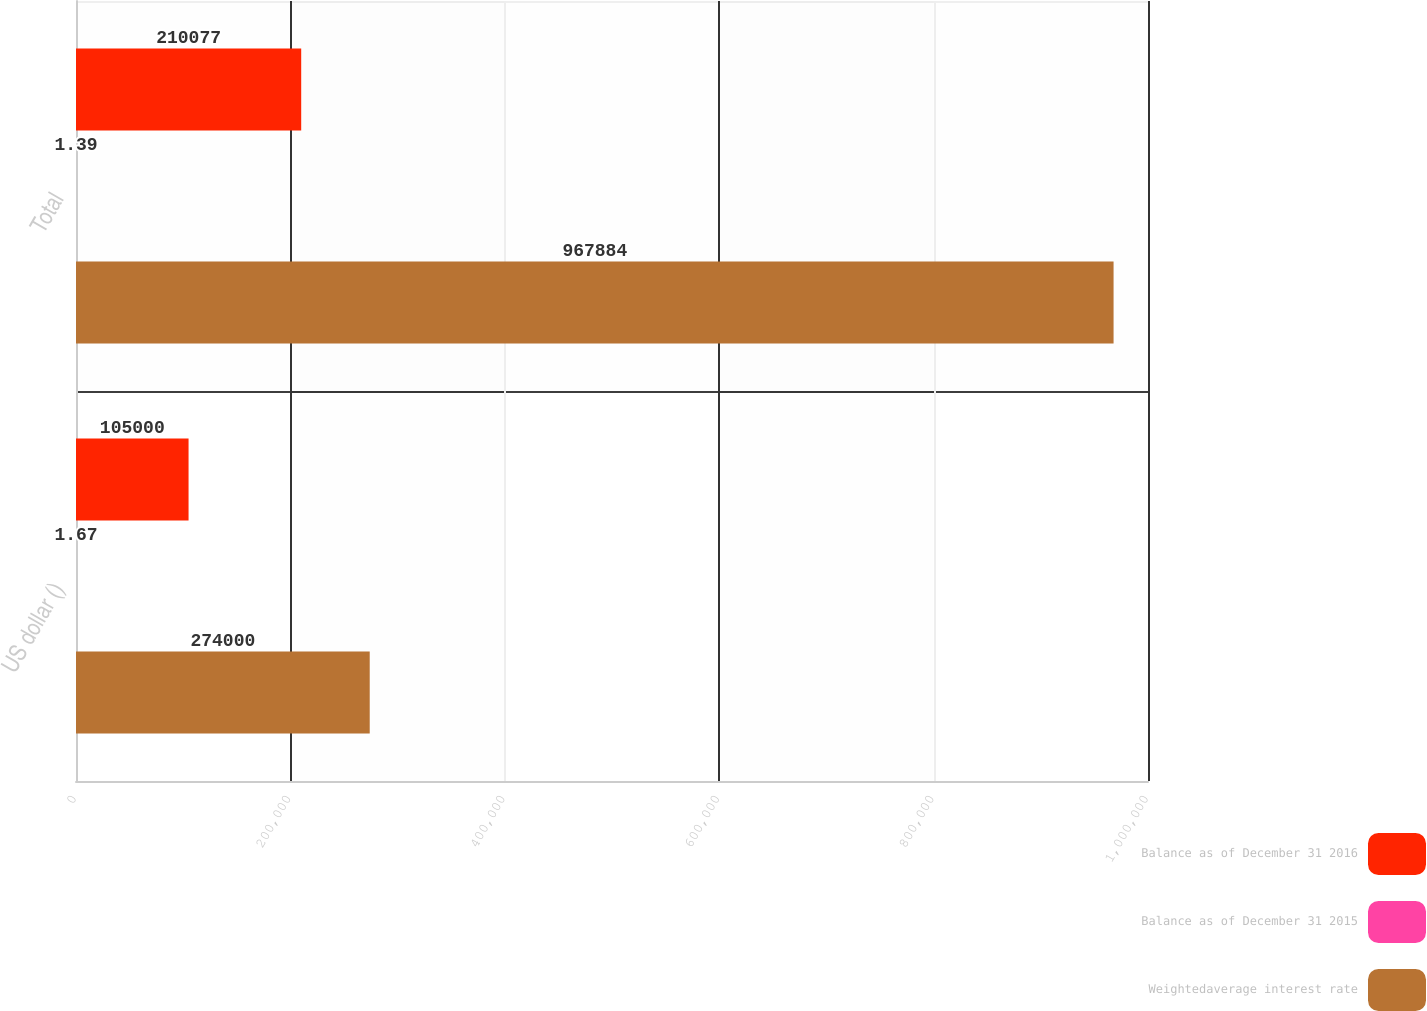Convert chart. <chart><loc_0><loc_0><loc_500><loc_500><stacked_bar_chart><ecel><fcel>US dollar ()<fcel>Total<nl><fcel>Balance as of December 31 2016<fcel>105000<fcel>210077<nl><fcel>Balance as of December 31 2015<fcel>1.67<fcel>1.39<nl><fcel>Weightedaverage interest rate<fcel>274000<fcel>967884<nl></chart> 